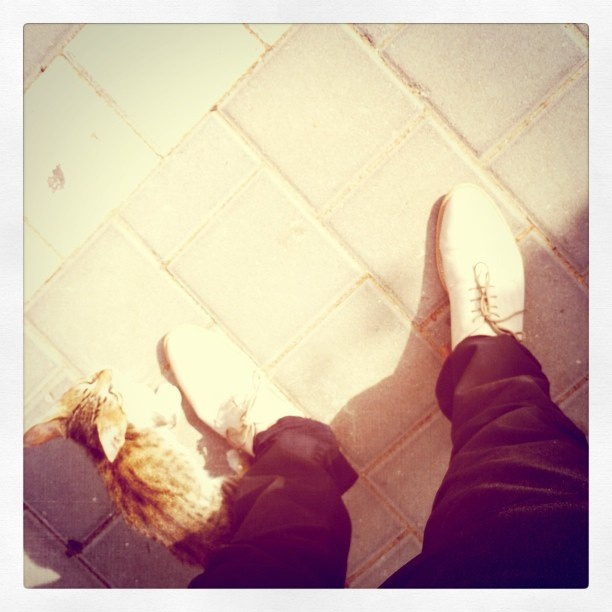Describe the objects in this image and their specific colors. I can see people in whitesmoke, purple, lightyellow, and navy tones and cat in whitesmoke, khaki, tan, brown, and purple tones in this image. 